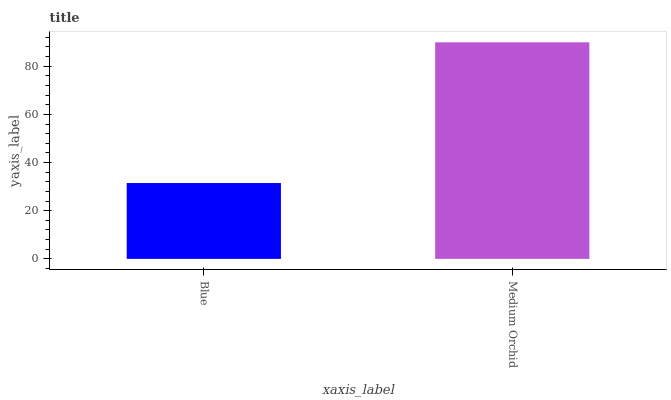Is Blue the minimum?
Answer yes or no. Yes. Is Medium Orchid the maximum?
Answer yes or no. Yes. Is Medium Orchid the minimum?
Answer yes or no. No. Is Medium Orchid greater than Blue?
Answer yes or no. Yes. Is Blue less than Medium Orchid?
Answer yes or no. Yes. Is Blue greater than Medium Orchid?
Answer yes or no. No. Is Medium Orchid less than Blue?
Answer yes or no. No. Is Medium Orchid the high median?
Answer yes or no. Yes. Is Blue the low median?
Answer yes or no. Yes. Is Blue the high median?
Answer yes or no. No. Is Medium Orchid the low median?
Answer yes or no. No. 